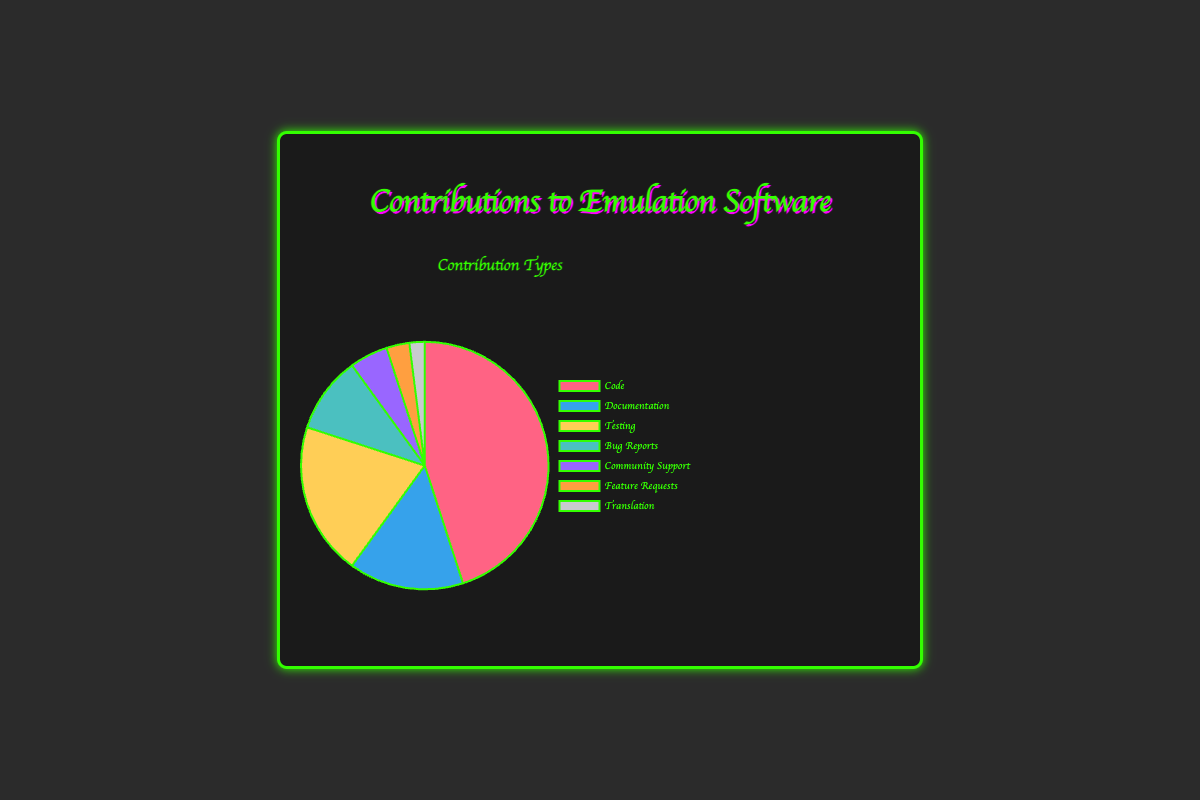What is the largest contribution type? The largest contribution type is determined by the highest percentage value in the chart, which is Code at 45%.
Answer: Code Which contribution type has the smallest percentage? The smallest contribution type is found by identifying the lowest percentage value in the chart, which is Translation with 2%.
Answer: Translation How much greater is the percentage of Code contributions compared to Documentation? Subtract the percentage of Documentation (15%) from the percentage of Code (45%) to find the difference: 45% - 15% = 30%.
Answer: 30% What is the combined percentage of Testing and Bug Reports? Add the percentages of Testing (20%) and Bug Reports (10%) together: 20% + 10% = 30%.
Answer: 30% Which contribution types have percentages greater than 10%? By examining the chart, the contribution types with percentages greater than 10% are Code (45%), Documentation (15%), and Testing (20%).
Answer: Code, Documentation, Testing What is the average percentage of all contribution types? To find the average, sum up all the percentages (45% + 15% + 20% + 10% + 5% + 3% + 2% = 100%) and divide by the number of contribution types (7): 100% / 7 ≈ 14.29%.
Answer: 14.29% What color represents the Community Support contributions on the chart? The chart uses different colors for each contribution type, and Community Support is represented by the color purple.
Answer: purple Are there more Feature Requests or Translation contributions? By comparing the percentages, Feature Requests (3%) are greater than Translation (2%).
Answer: Feature Requests What is the total percentage of contributions that are neither Code nor Testing? Add the percentages of all contributions except Code (45%) and Testing (20%): 15% (Documentation) + 10% (Bug Reports) + 5% (Community Support) + 3% (Feature Requests) + 2% (Translation) = 35%.
Answer: 35% By how much does the percentage of Bug Reports exceed that of Community Support? Subtract the percentage of Community Support (5%) from Bug Reports (10%): 10% - 5% = 5%.
Answer: 5% 